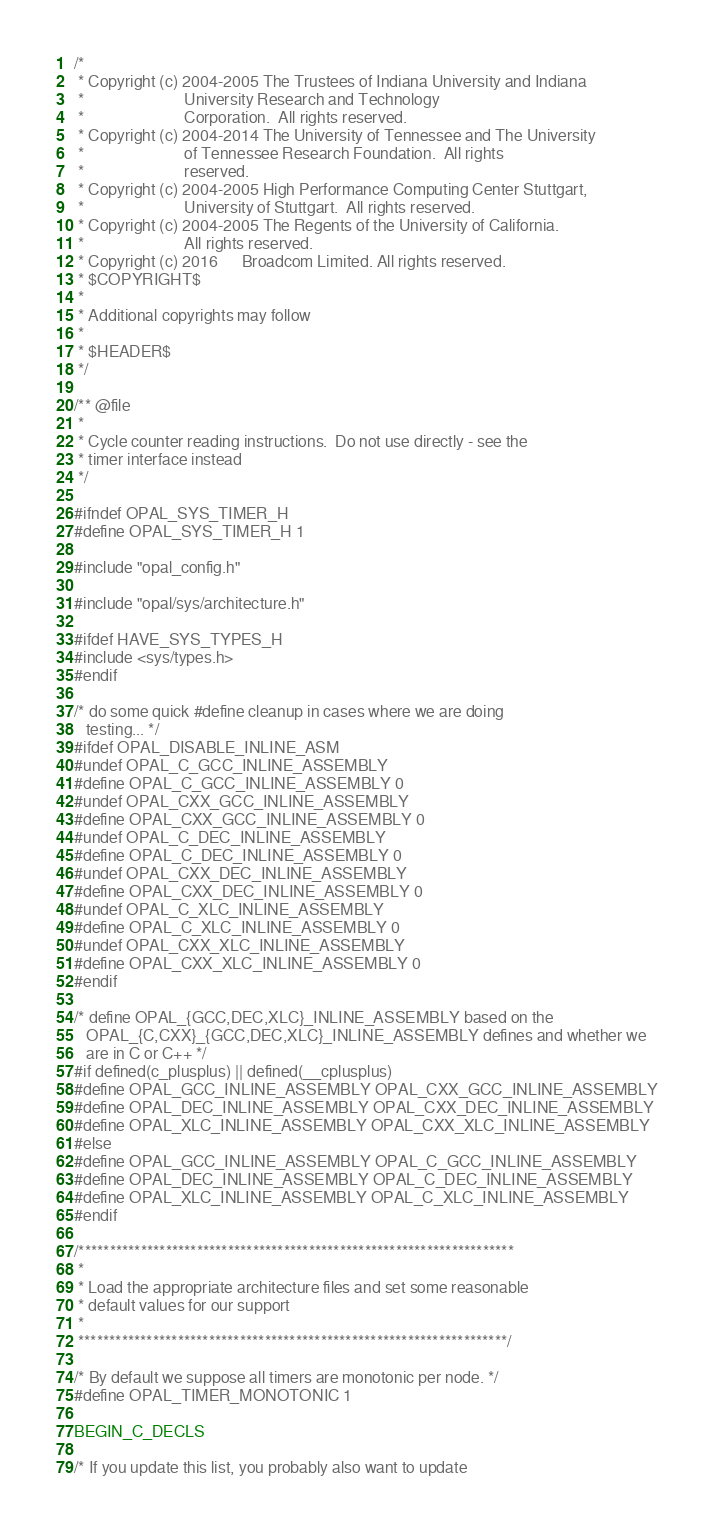<code> <loc_0><loc_0><loc_500><loc_500><_C_>/*
 * Copyright (c) 2004-2005 The Trustees of Indiana University and Indiana
 *                         University Research and Technology
 *                         Corporation.  All rights reserved.
 * Copyright (c) 2004-2014 The University of Tennessee and The University
 *                         of Tennessee Research Foundation.  All rights
 *                         reserved.
 * Copyright (c) 2004-2005 High Performance Computing Center Stuttgart,
 *                         University of Stuttgart.  All rights reserved.
 * Copyright (c) 2004-2005 The Regents of the University of California.
 *                         All rights reserved.
 * Copyright (c) 2016      Broadcom Limited. All rights reserved.
 * $COPYRIGHT$
 *
 * Additional copyrights may follow
 *
 * $HEADER$
 */

/** @file
 *
 * Cycle counter reading instructions.  Do not use directly - see the
 * timer interface instead
 */

#ifndef OPAL_SYS_TIMER_H
#define OPAL_SYS_TIMER_H 1

#include "opal_config.h"

#include "opal/sys/architecture.h"

#ifdef HAVE_SYS_TYPES_H
#include <sys/types.h>
#endif

/* do some quick #define cleanup in cases where we are doing
   testing... */
#ifdef OPAL_DISABLE_INLINE_ASM
#undef OPAL_C_GCC_INLINE_ASSEMBLY
#define OPAL_C_GCC_INLINE_ASSEMBLY 0
#undef OPAL_CXX_GCC_INLINE_ASSEMBLY
#define OPAL_CXX_GCC_INLINE_ASSEMBLY 0
#undef OPAL_C_DEC_INLINE_ASSEMBLY
#define OPAL_C_DEC_INLINE_ASSEMBLY 0
#undef OPAL_CXX_DEC_INLINE_ASSEMBLY
#define OPAL_CXX_DEC_INLINE_ASSEMBLY 0
#undef OPAL_C_XLC_INLINE_ASSEMBLY
#define OPAL_C_XLC_INLINE_ASSEMBLY 0
#undef OPAL_CXX_XLC_INLINE_ASSEMBLY
#define OPAL_CXX_XLC_INLINE_ASSEMBLY 0
#endif

/* define OPAL_{GCC,DEC,XLC}_INLINE_ASSEMBLY based on the
   OPAL_{C,CXX}_{GCC,DEC,XLC}_INLINE_ASSEMBLY defines and whether we
   are in C or C++ */
#if defined(c_plusplus) || defined(__cplusplus)
#define OPAL_GCC_INLINE_ASSEMBLY OPAL_CXX_GCC_INLINE_ASSEMBLY
#define OPAL_DEC_INLINE_ASSEMBLY OPAL_CXX_DEC_INLINE_ASSEMBLY
#define OPAL_XLC_INLINE_ASSEMBLY OPAL_CXX_XLC_INLINE_ASSEMBLY
#else
#define OPAL_GCC_INLINE_ASSEMBLY OPAL_C_GCC_INLINE_ASSEMBLY
#define OPAL_DEC_INLINE_ASSEMBLY OPAL_C_DEC_INLINE_ASSEMBLY
#define OPAL_XLC_INLINE_ASSEMBLY OPAL_C_XLC_INLINE_ASSEMBLY
#endif

/**********************************************************************
 *
 * Load the appropriate architecture files and set some reasonable
 * default values for our support
 *
 *********************************************************************/

/* By default we suppose all timers are monotonic per node. */
#define OPAL_TIMER_MONOTONIC 1

BEGIN_C_DECLS

/* If you update this list, you probably also want to update</code> 